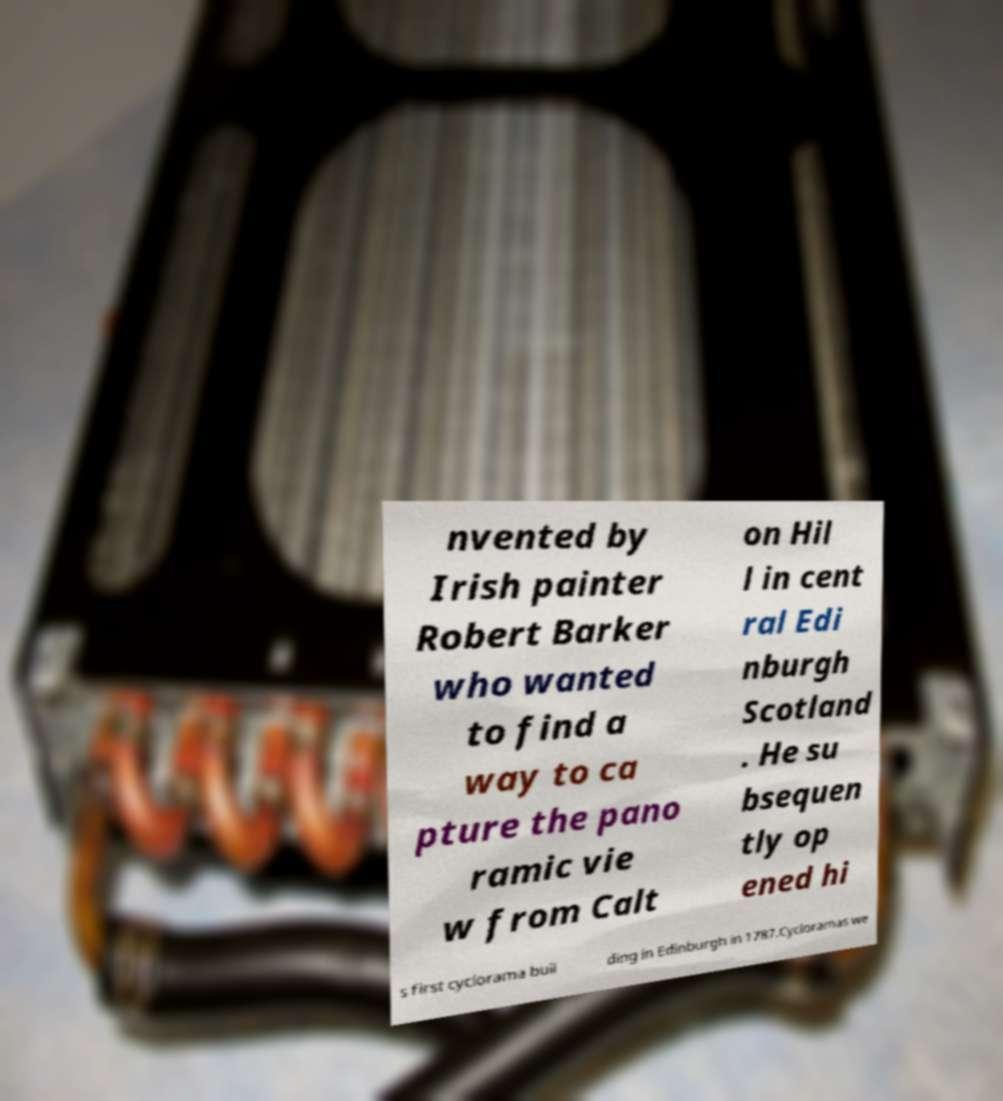I need the written content from this picture converted into text. Can you do that? nvented by Irish painter Robert Barker who wanted to find a way to ca pture the pano ramic vie w from Calt on Hil l in cent ral Edi nburgh Scotland . He su bsequen tly op ened hi s first cyclorama buil ding in Edinburgh in 1787.Cycloramas we 